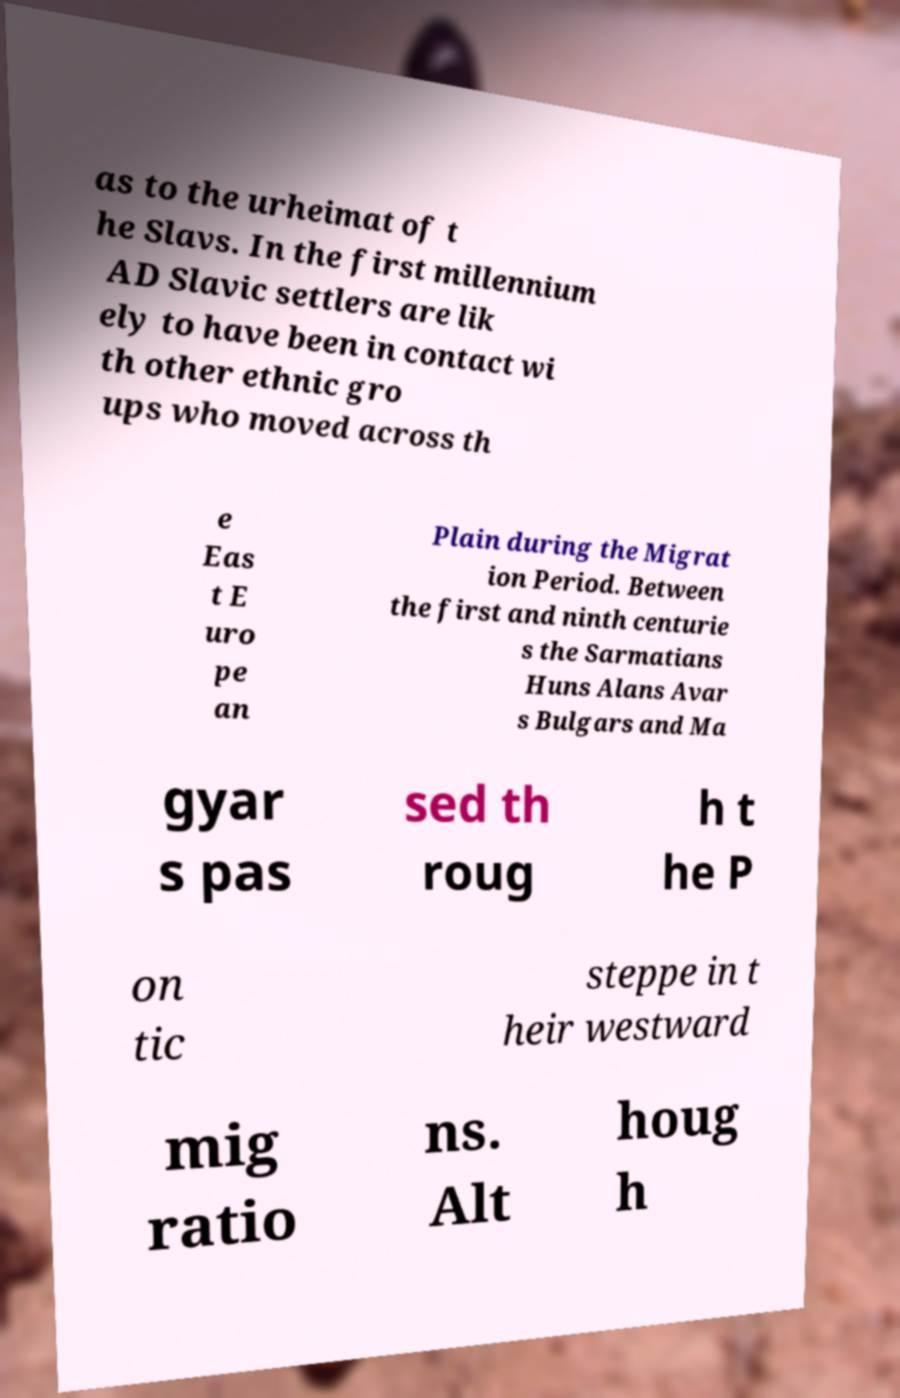Please identify and transcribe the text found in this image. as to the urheimat of t he Slavs. In the first millennium AD Slavic settlers are lik ely to have been in contact wi th other ethnic gro ups who moved across th e Eas t E uro pe an Plain during the Migrat ion Period. Between the first and ninth centurie s the Sarmatians Huns Alans Avar s Bulgars and Ma gyar s pas sed th roug h t he P on tic steppe in t heir westward mig ratio ns. Alt houg h 